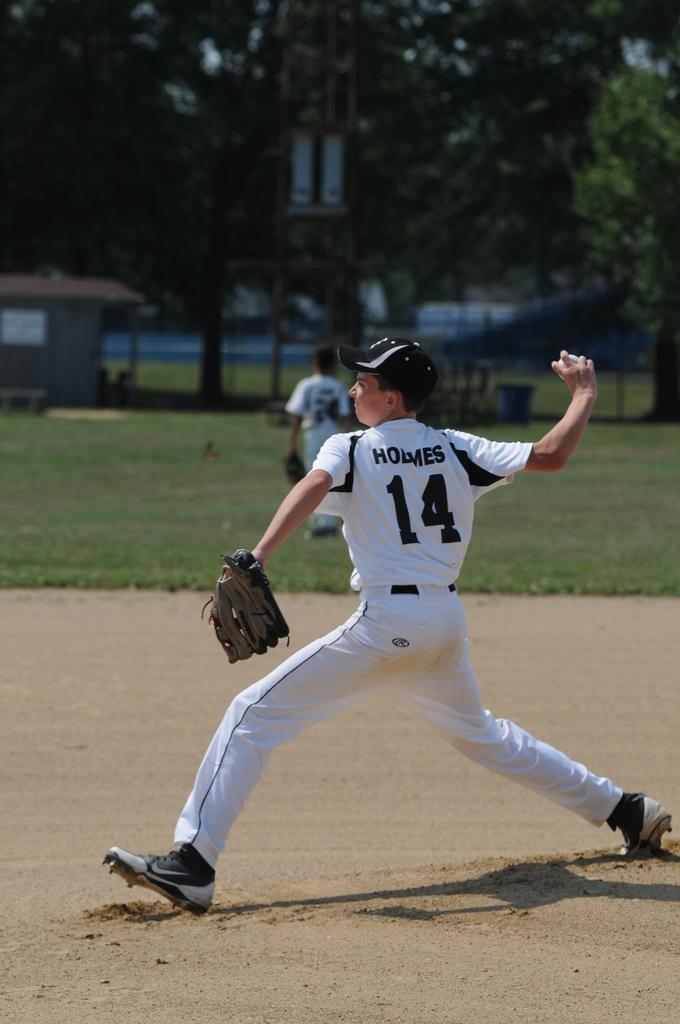<image>
Create a compact narrative representing the image presented. A baseball player with 14 on his jersey is about to throw the ball. 